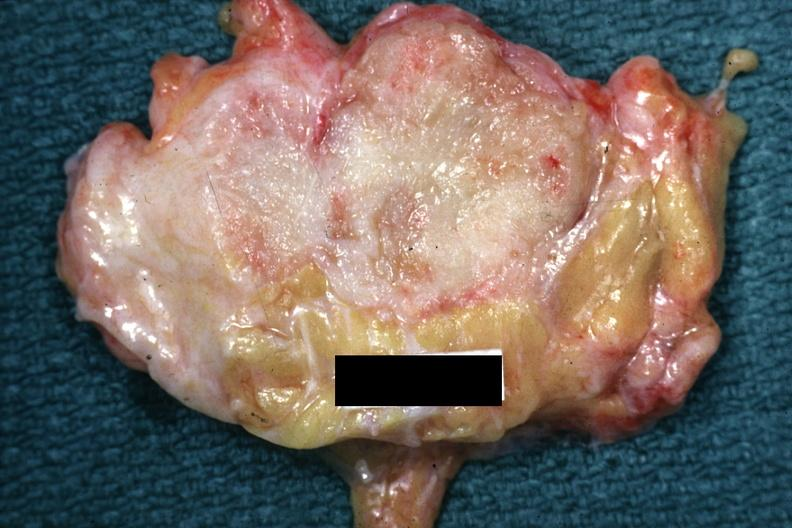does beckwith-wiedemann syndrome show good example of a breast carcinoma?
Answer the question using a single word or phrase. No 